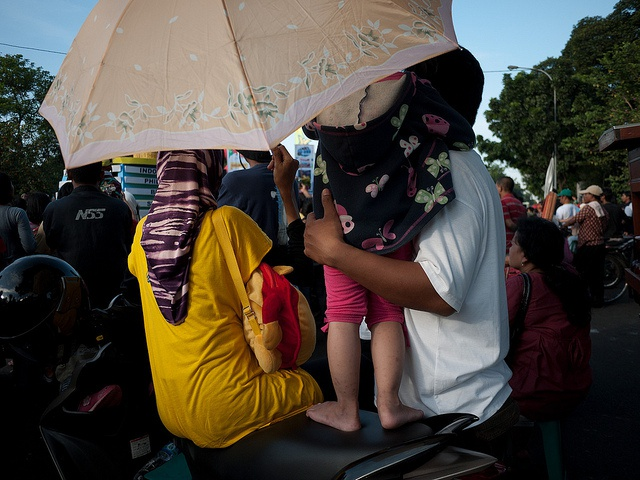Describe the objects in this image and their specific colors. I can see umbrella in darkgray, gray, and tan tones, people in darkgray, black, olive, maroon, and orange tones, people in darkgray, black, gray, and maroon tones, people in darkgray, black, gray, and maroon tones, and motorcycle in darkgray, black, orange, maroon, and purple tones in this image. 